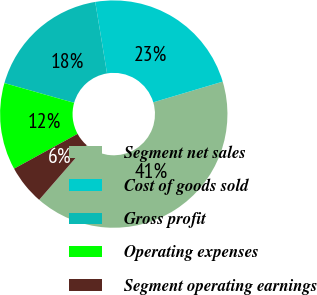Convert chart. <chart><loc_0><loc_0><loc_500><loc_500><pie_chart><fcel>Segment net sales<fcel>Cost of goods sold<fcel>Gross profit<fcel>Operating expenses<fcel>Segment operating earnings<nl><fcel>41.0%<fcel>23.0%<fcel>18.0%<fcel>12.37%<fcel>5.63%<nl></chart> 